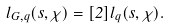Convert formula to latex. <formula><loc_0><loc_0><loc_500><loc_500>l _ { G , q } ( s , \chi ) = [ 2 ] l _ { q } ( s , \chi ) .</formula> 